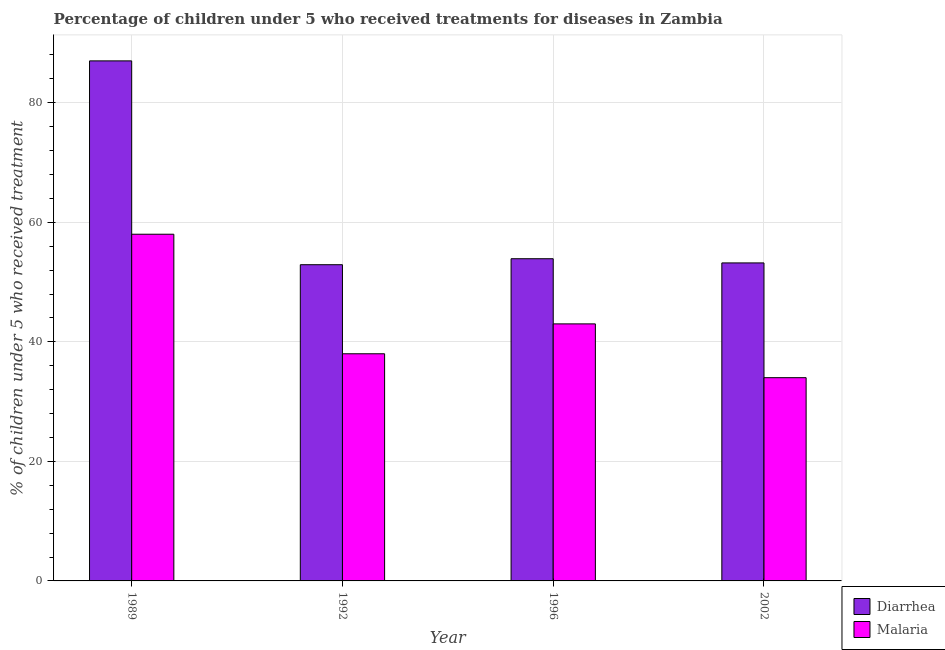How many different coloured bars are there?
Provide a short and direct response. 2. How many bars are there on the 1st tick from the right?
Keep it short and to the point. 2. What is the percentage of children who received treatment for diarrhoea in 1989?
Ensure brevity in your answer.  87. Across all years, what is the minimum percentage of children who received treatment for diarrhoea?
Ensure brevity in your answer.  52.9. In which year was the percentage of children who received treatment for malaria maximum?
Make the answer very short. 1989. What is the total percentage of children who received treatment for malaria in the graph?
Offer a very short reply. 173. What is the difference between the percentage of children who received treatment for diarrhoea in 1996 and that in 2002?
Ensure brevity in your answer.  0.7. What is the difference between the percentage of children who received treatment for diarrhoea in 1996 and the percentage of children who received treatment for malaria in 2002?
Provide a short and direct response. 0.7. What is the average percentage of children who received treatment for diarrhoea per year?
Give a very brief answer. 61.75. In how many years, is the percentage of children who received treatment for diarrhoea greater than 48 %?
Offer a terse response. 4. What is the ratio of the percentage of children who received treatment for malaria in 1989 to that in 2002?
Offer a terse response. 1.71. What is the difference between the highest and the second highest percentage of children who received treatment for diarrhoea?
Provide a short and direct response. 33.1. What does the 2nd bar from the left in 1992 represents?
Your answer should be very brief. Malaria. What does the 1st bar from the right in 2002 represents?
Your answer should be compact. Malaria. How many bars are there?
Make the answer very short. 8. Are all the bars in the graph horizontal?
Offer a terse response. No. How many years are there in the graph?
Keep it short and to the point. 4. Are the values on the major ticks of Y-axis written in scientific E-notation?
Make the answer very short. No. Does the graph contain grids?
Provide a short and direct response. Yes. How many legend labels are there?
Your response must be concise. 2. What is the title of the graph?
Offer a terse response. Percentage of children under 5 who received treatments for diseases in Zambia. Does "Resident" appear as one of the legend labels in the graph?
Keep it short and to the point. No. What is the label or title of the X-axis?
Offer a terse response. Year. What is the label or title of the Y-axis?
Your answer should be compact. % of children under 5 who received treatment. What is the % of children under 5 who received treatment in Malaria in 1989?
Your answer should be compact. 58. What is the % of children under 5 who received treatment of Diarrhea in 1992?
Your response must be concise. 52.9. What is the % of children under 5 who received treatment in Diarrhea in 1996?
Ensure brevity in your answer.  53.9. What is the % of children under 5 who received treatment in Malaria in 1996?
Offer a terse response. 43. What is the % of children under 5 who received treatment in Diarrhea in 2002?
Keep it short and to the point. 53.2. Across all years, what is the maximum % of children under 5 who received treatment of Diarrhea?
Provide a short and direct response. 87. Across all years, what is the minimum % of children under 5 who received treatment of Diarrhea?
Your response must be concise. 52.9. Across all years, what is the minimum % of children under 5 who received treatment in Malaria?
Your answer should be compact. 34. What is the total % of children under 5 who received treatment in Diarrhea in the graph?
Your answer should be compact. 247. What is the total % of children under 5 who received treatment of Malaria in the graph?
Provide a succinct answer. 173. What is the difference between the % of children under 5 who received treatment of Diarrhea in 1989 and that in 1992?
Offer a very short reply. 34.1. What is the difference between the % of children under 5 who received treatment in Malaria in 1989 and that in 1992?
Keep it short and to the point. 20. What is the difference between the % of children under 5 who received treatment in Diarrhea in 1989 and that in 1996?
Give a very brief answer. 33.1. What is the difference between the % of children under 5 who received treatment in Diarrhea in 1989 and that in 2002?
Ensure brevity in your answer.  33.8. What is the difference between the % of children under 5 who received treatment of Malaria in 1992 and that in 1996?
Your response must be concise. -5. What is the difference between the % of children under 5 who received treatment in Malaria in 1996 and that in 2002?
Offer a terse response. 9. What is the difference between the % of children under 5 who received treatment of Diarrhea in 1989 and the % of children under 5 who received treatment of Malaria in 1992?
Give a very brief answer. 49. What is the difference between the % of children under 5 who received treatment of Diarrhea in 1992 and the % of children under 5 who received treatment of Malaria in 1996?
Make the answer very short. 9.9. What is the difference between the % of children under 5 who received treatment in Diarrhea in 1996 and the % of children under 5 who received treatment in Malaria in 2002?
Offer a terse response. 19.9. What is the average % of children under 5 who received treatment of Diarrhea per year?
Your answer should be very brief. 61.75. What is the average % of children under 5 who received treatment in Malaria per year?
Your answer should be compact. 43.25. In the year 1992, what is the difference between the % of children under 5 who received treatment in Diarrhea and % of children under 5 who received treatment in Malaria?
Offer a terse response. 14.9. What is the ratio of the % of children under 5 who received treatment in Diarrhea in 1989 to that in 1992?
Offer a terse response. 1.64. What is the ratio of the % of children under 5 who received treatment in Malaria in 1989 to that in 1992?
Provide a short and direct response. 1.53. What is the ratio of the % of children under 5 who received treatment of Diarrhea in 1989 to that in 1996?
Keep it short and to the point. 1.61. What is the ratio of the % of children under 5 who received treatment in Malaria in 1989 to that in 1996?
Provide a short and direct response. 1.35. What is the ratio of the % of children under 5 who received treatment in Diarrhea in 1989 to that in 2002?
Give a very brief answer. 1.64. What is the ratio of the % of children under 5 who received treatment in Malaria in 1989 to that in 2002?
Give a very brief answer. 1.71. What is the ratio of the % of children under 5 who received treatment of Diarrhea in 1992 to that in 1996?
Offer a terse response. 0.98. What is the ratio of the % of children under 5 who received treatment in Malaria in 1992 to that in 1996?
Ensure brevity in your answer.  0.88. What is the ratio of the % of children under 5 who received treatment in Malaria in 1992 to that in 2002?
Offer a very short reply. 1.12. What is the ratio of the % of children under 5 who received treatment of Diarrhea in 1996 to that in 2002?
Offer a terse response. 1.01. What is the ratio of the % of children under 5 who received treatment of Malaria in 1996 to that in 2002?
Provide a short and direct response. 1.26. What is the difference between the highest and the second highest % of children under 5 who received treatment of Diarrhea?
Your answer should be very brief. 33.1. What is the difference between the highest and the lowest % of children under 5 who received treatment of Diarrhea?
Ensure brevity in your answer.  34.1. 